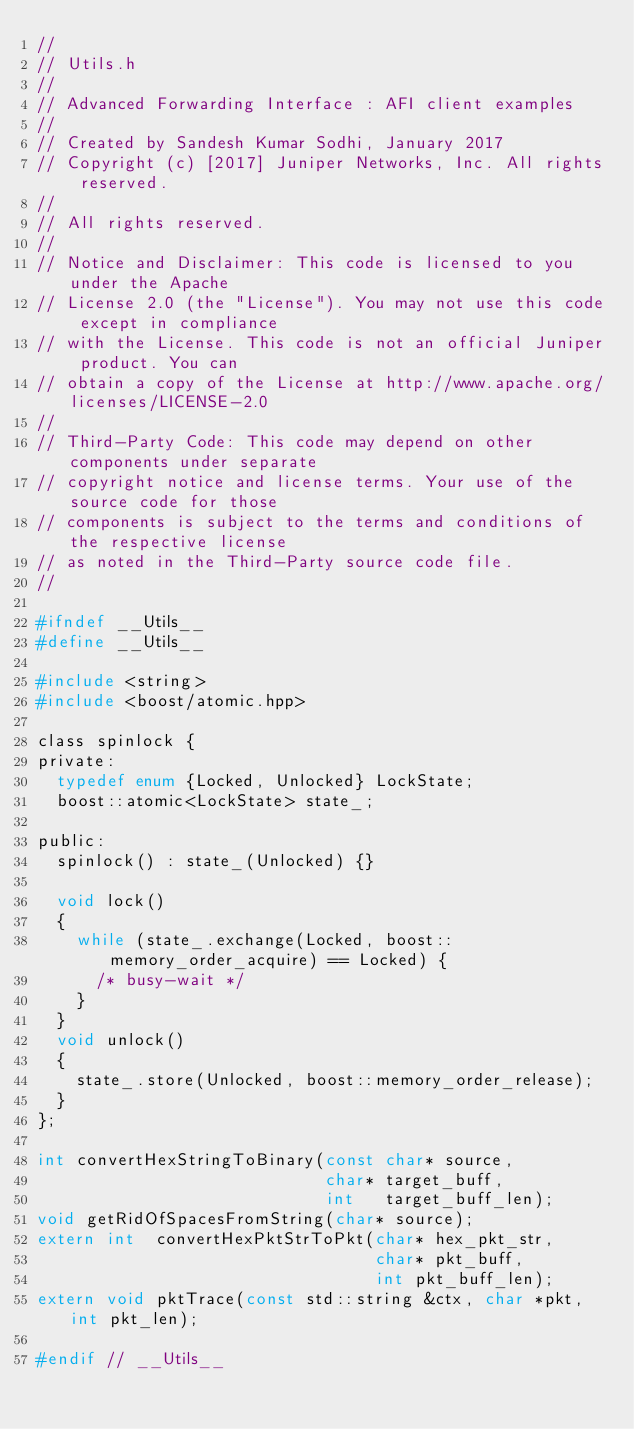<code> <loc_0><loc_0><loc_500><loc_500><_C_>//
// Utils.h
//
// Advanced Forwarding Interface : AFI client examples
//
// Created by Sandesh Kumar Sodhi, January 2017
// Copyright (c) [2017] Juniper Networks, Inc. All rights reserved.
//
// All rights reserved.
//
// Notice and Disclaimer: This code is licensed to you under the Apache
// License 2.0 (the "License"). You may not use this code except in compliance
// with the License. This code is not an official Juniper product. You can
// obtain a copy of the License at http://www.apache.org/licenses/LICENSE-2.0
//
// Third-Party Code: This code may depend on other components under separate
// copyright notice and license terms. Your use of the source code for those
// components is subject to the terms and conditions of the respective license
// as noted in the Third-Party source code file.
//

#ifndef __Utils__
#define __Utils__

#include <string>
#include <boost/atomic.hpp>

class spinlock {
private:
  typedef enum {Locked, Unlocked} LockState;
  boost::atomic<LockState> state_;

public:
  spinlock() : state_(Unlocked) {}

  void lock()
  {
    while (state_.exchange(Locked, boost::memory_order_acquire) == Locked) {
      /* busy-wait */
    }
  }
  void unlock()
  {
    state_.store(Unlocked, boost::memory_order_release);
  }
};

int convertHexStringToBinary(const char* source, 
                             char* target_buff, 
                             int   target_buff_len);
void getRidOfSpacesFromString(char* source);
extern int  convertHexPktStrToPkt(char* hex_pkt_str, 
                                  char* pkt_buff, 
                                  int pkt_buff_len);
extern void pktTrace(const std::string &ctx, char *pkt, int pkt_len);

#endif // __Utils__
</code> 